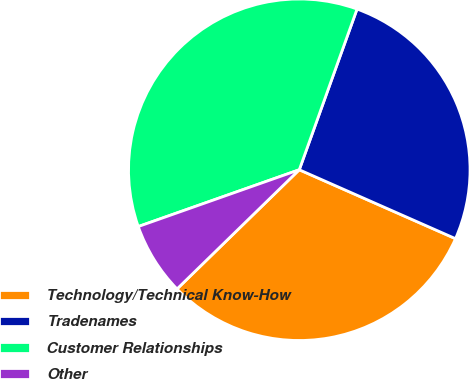Convert chart to OTSL. <chart><loc_0><loc_0><loc_500><loc_500><pie_chart><fcel>Technology/Technical Know-How<fcel>Tradenames<fcel>Customer Relationships<fcel>Other<nl><fcel>31.09%<fcel>26.12%<fcel>35.89%<fcel>6.9%<nl></chart> 